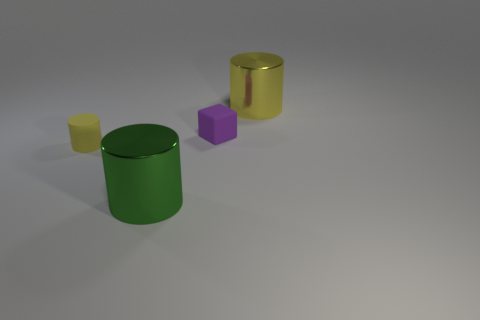Add 3 gray rubber things. How many objects exist? 7 Subtract all blocks. How many objects are left? 3 Subtract 0 gray cylinders. How many objects are left? 4 Subtract all small red matte balls. Subtract all matte things. How many objects are left? 2 Add 3 green metal objects. How many green metal objects are left? 4 Add 4 big cylinders. How many big cylinders exist? 6 